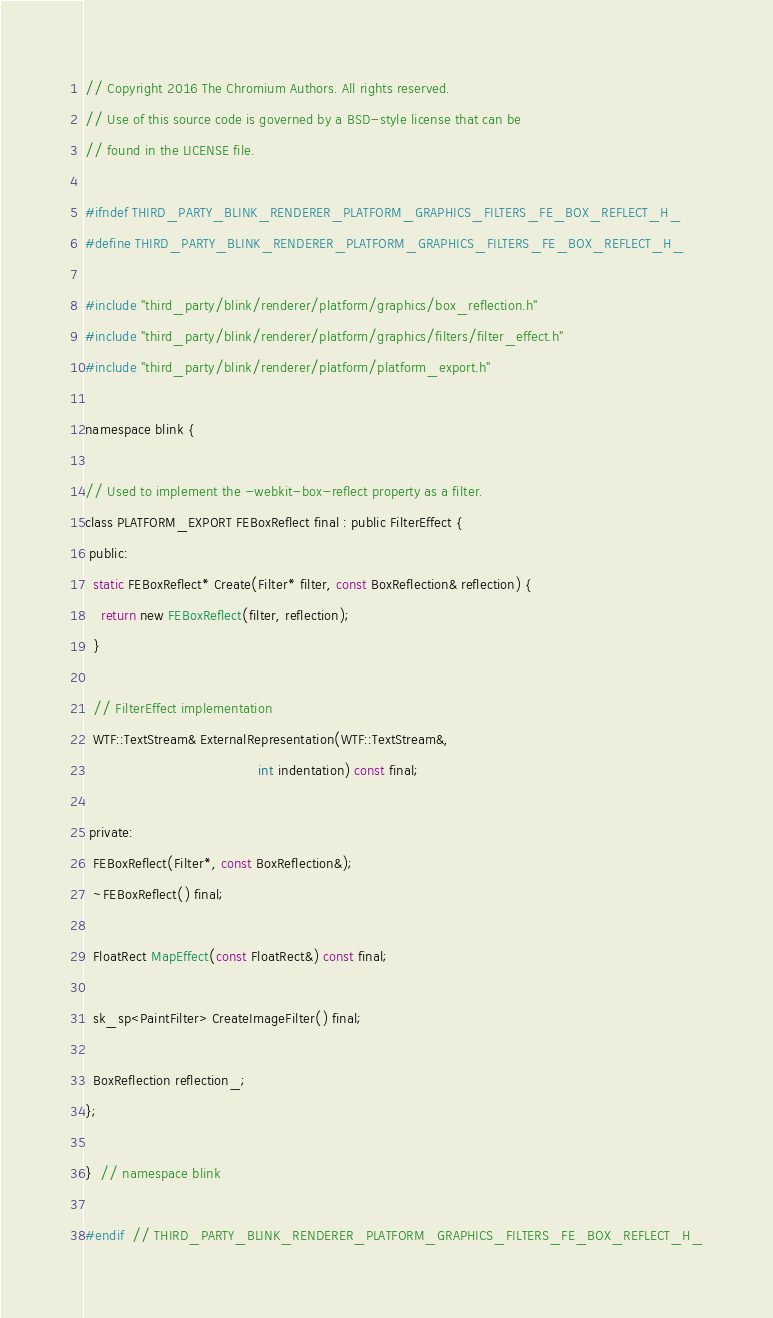Convert code to text. <code><loc_0><loc_0><loc_500><loc_500><_C_>// Copyright 2016 The Chromium Authors. All rights reserved.
// Use of this source code is governed by a BSD-style license that can be
// found in the LICENSE file.

#ifndef THIRD_PARTY_BLINK_RENDERER_PLATFORM_GRAPHICS_FILTERS_FE_BOX_REFLECT_H_
#define THIRD_PARTY_BLINK_RENDERER_PLATFORM_GRAPHICS_FILTERS_FE_BOX_REFLECT_H_

#include "third_party/blink/renderer/platform/graphics/box_reflection.h"
#include "third_party/blink/renderer/platform/graphics/filters/filter_effect.h"
#include "third_party/blink/renderer/platform/platform_export.h"

namespace blink {

// Used to implement the -webkit-box-reflect property as a filter.
class PLATFORM_EXPORT FEBoxReflect final : public FilterEffect {
 public:
  static FEBoxReflect* Create(Filter* filter, const BoxReflection& reflection) {
    return new FEBoxReflect(filter, reflection);
  }

  // FilterEffect implementation
  WTF::TextStream& ExternalRepresentation(WTF::TextStream&,
                                          int indentation) const final;

 private:
  FEBoxReflect(Filter*, const BoxReflection&);
  ~FEBoxReflect() final;

  FloatRect MapEffect(const FloatRect&) const final;

  sk_sp<PaintFilter> CreateImageFilter() final;

  BoxReflection reflection_;
};

}  // namespace blink

#endif  // THIRD_PARTY_BLINK_RENDERER_PLATFORM_GRAPHICS_FILTERS_FE_BOX_REFLECT_H_
</code> 